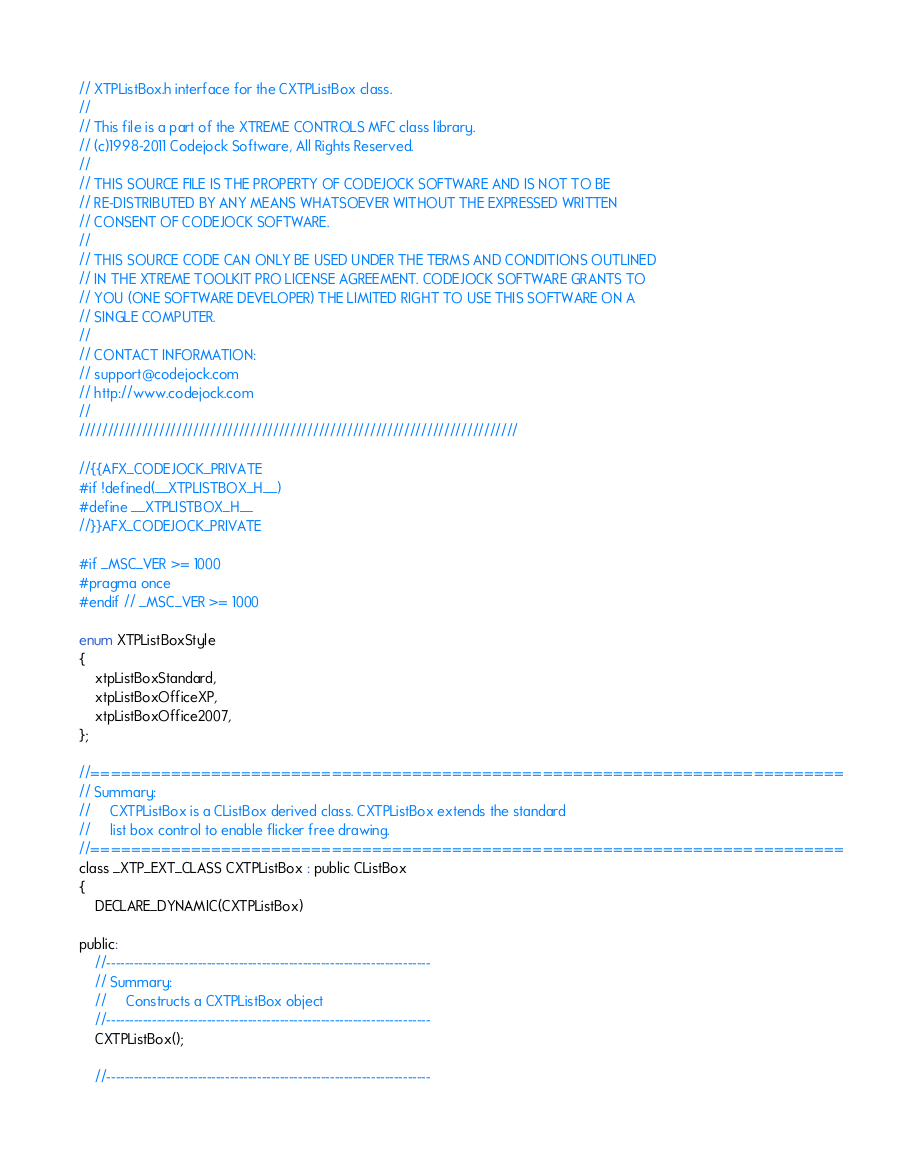Convert code to text. <code><loc_0><loc_0><loc_500><loc_500><_C_>// XTPListBox.h interface for the CXTPListBox class.
//
// This file is a part of the XTREME CONTROLS MFC class library.
// (c)1998-2011 Codejock Software, All Rights Reserved.
//
// THIS SOURCE FILE IS THE PROPERTY OF CODEJOCK SOFTWARE AND IS NOT TO BE
// RE-DISTRIBUTED BY ANY MEANS WHATSOEVER WITHOUT THE EXPRESSED WRITTEN
// CONSENT OF CODEJOCK SOFTWARE.
//
// THIS SOURCE CODE CAN ONLY BE USED UNDER THE TERMS AND CONDITIONS OUTLINED
// IN THE XTREME TOOLKIT PRO LICENSE AGREEMENT. CODEJOCK SOFTWARE GRANTS TO
// YOU (ONE SOFTWARE DEVELOPER) THE LIMITED RIGHT TO USE THIS SOFTWARE ON A
// SINGLE COMPUTER.
//
// CONTACT INFORMATION:
// support@codejock.com
// http://www.codejock.com
//
/////////////////////////////////////////////////////////////////////////////

//{{AFX_CODEJOCK_PRIVATE
#if !defined(__XTPLISTBOX_H__)
#define __XTPLISTBOX_H__
//}}AFX_CODEJOCK_PRIVATE

#if _MSC_VER >= 1000
#pragma once
#endif // _MSC_VER >= 1000

enum XTPListBoxStyle
{
	xtpListBoxStandard,
	xtpListBoxOfficeXP,
	xtpListBoxOffice2007,
};

//===========================================================================
// Summary:
//     CXTPListBox is a CListBox derived class. CXTPListBox extends the standard
//     list box control to enable flicker free drawing.
//===========================================================================
class _XTP_EXT_CLASS CXTPListBox : public CListBox
{
	DECLARE_DYNAMIC(CXTPListBox)

public:
	//-----------------------------------------------------------------------
	// Summary:
	//     Constructs a CXTPListBox object
	//-----------------------------------------------------------------------
	CXTPListBox();

	//-----------------------------------------------------------------------</code> 